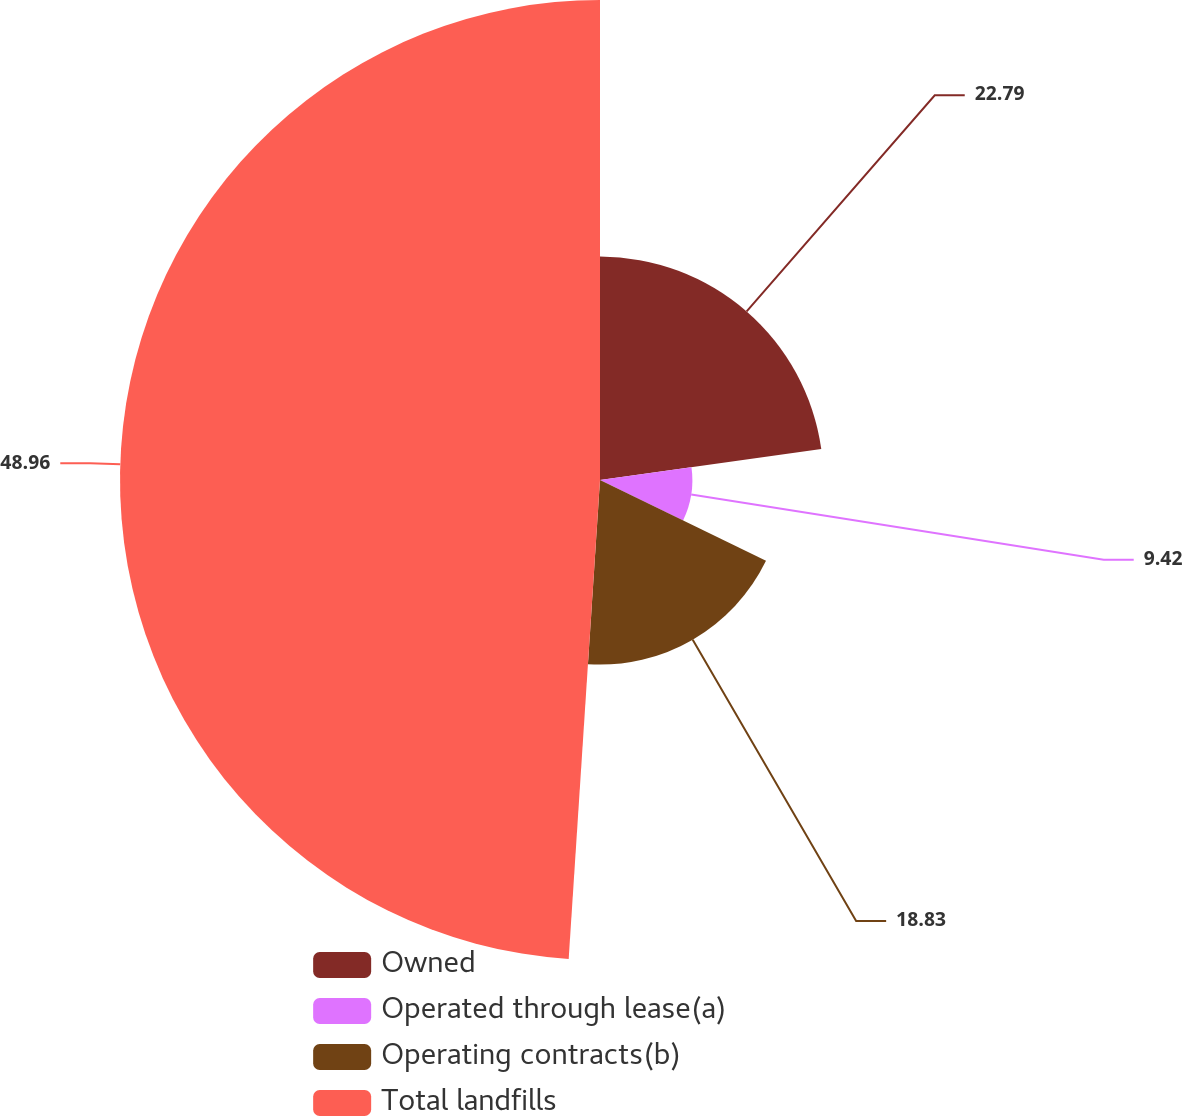<chart> <loc_0><loc_0><loc_500><loc_500><pie_chart><fcel>Owned<fcel>Operated through lease(a)<fcel>Operating contracts(b)<fcel>Total landfills<nl><fcel>22.79%<fcel>9.42%<fcel>18.83%<fcel>48.96%<nl></chart> 